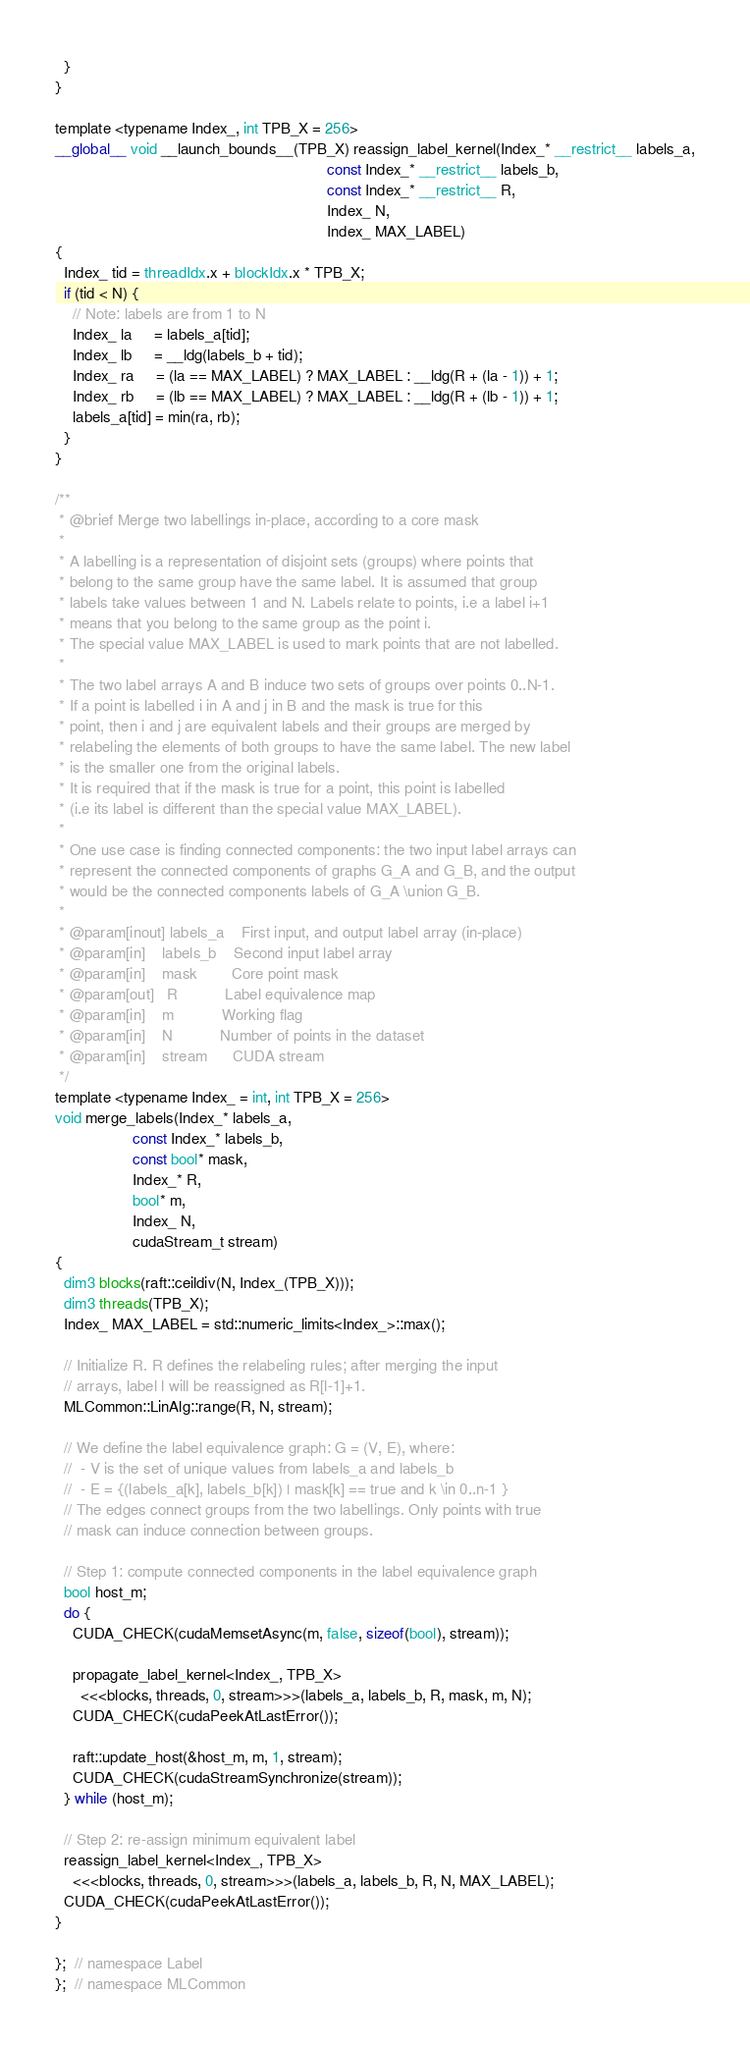<code> <loc_0><loc_0><loc_500><loc_500><_Cuda_>  }
}

template <typename Index_, int TPB_X = 256>
__global__ void __launch_bounds__(TPB_X) reassign_label_kernel(Index_* __restrict__ labels_a,
                                                               const Index_* __restrict__ labels_b,
                                                               const Index_* __restrict__ R,
                                                               Index_ N,
                                                               Index_ MAX_LABEL)
{
  Index_ tid = threadIdx.x + blockIdx.x * TPB_X;
  if (tid < N) {
    // Note: labels are from 1 to N
    Index_ la     = labels_a[tid];
    Index_ lb     = __ldg(labels_b + tid);
    Index_ ra     = (la == MAX_LABEL) ? MAX_LABEL : __ldg(R + (la - 1)) + 1;
    Index_ rb     = (lb == MAX_LABEL) ? MAX_LABEL : __ldg(R + (lb - 1)) + 1;
    labels_a[tid] = min(ra, rb);
  }
}

/**
 * @brief Merge two labellings in-place, according to a core mask
 *
 * A labelling is a representation of disjoint sets (groups) where points that
 * belong to the same group have the same label. It is assumed that group
 * labels take values between 1 and N. Labels relate to points, i.e a label i+1
 * means that you belong to the same group as the point i.
 * The special value MAX_LABEL is used to mark points that are not labelled.
 *
 * The two label arrays A and B induce two sets of groups over points 0..N-1.
 * If a point is labelled i in A and j in B and the mask is true for this
 * point, then i and j are equivalent labels and their groups are merged by
 * relabeling the elements of both groups to have the same label. The new label
 * is the smaller one from the original labels.
 * It is required that if the mask is true for a point, this point is labelled
 * (i.e its label is different than the special value MAX_LABEL).
 *
 * One use case is finding connected components: the two input label arrays can
 * represent the connected components of graphs G_A and G_B, and the output
 * would be the connected components labels of G_A \union G_B.
 *
 * @param[inout] labels_a    First input, and output label array (in-place)
 * @param[in]    labels_b    Second input label array
 * @param[in]    mask        Core point mask
 * @param[out]   R           Label equivalence map
 * @param[in]    m           Working flag
 * @param[in]    N           Number of points in the dataset
 * @param[in]    stream      CUDA stream
 */
template <typename Index_ = int, int TPB_X = 256>
void merge_labels(Index_* labels_a,
                  const Index_* labels_b,
                  const bool* mask,
                  Index_* R,
                  bool* m,
                  Index_ N,
                  cudaStream_t stream)
{
  dim3 blocks(raft::ceildiv(N, Index_(TPB_X)));
  dim3 threads(TPB_X);
  Index_ MAX_LABEL = std::numeric_limits<Index_>::max();

  // Initialize R. R defines the relabeling rules; after merging the input
  // arrays, label l will be reassigned as R[l-1]+1.
  MLCommon::LinAlg::range(R, N, stream);

  // We define the label equivalence graph: G = (V, E), where:
  //  - V is the set of unique values from labels_a and labels_b
  //  - E = {(labels_a[k], labels_b[k]) | mask[k] == true and k \in 0..n-1 }
  // The edges connect groups from the two labellings. Only points with true
  // mask can induce connection between groups.

  // Step 1: compute connected components in the label equivalence graph
  bool host_m;
  do {
    CUDA_CHECK(cudaMemsetAsync(m, false, sizeof(bool), stream));

    propagate_label_kernel<Index_, TPB_X>
      <<<blocks, threads, 0, stream>>>(labels_a, labels_b, R, mask, m, N);
    CUDA_CHECK(cudaPeekAtLastError());

    raft::update_host(&host_m, m, 1, stream);
    CUDA_CHECK(cudaStreamSynchronize(stream));
  } while (host_m);

  // Step 2: re-assign minimum equivalent label
  reassign_label_kernel<Index_, TPB_X>
    <<<blocks, threads, 0, stream>>>(labels_a, labels_b, R, N, MAX_LABEL);
  CUDA_CHECK(cudaPeekAtLastError());
}

};  // namespace Label
};  // namespace MLCommon</code> 